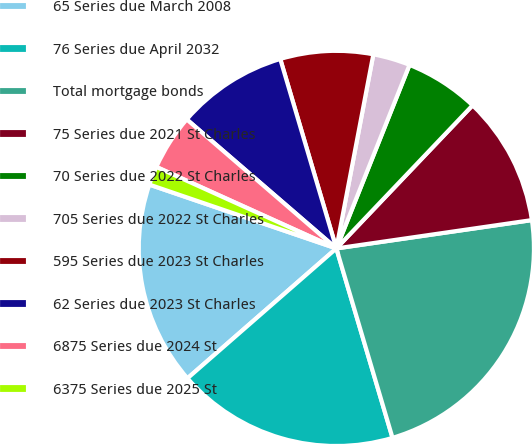Convert chart. <chart><loc_0><loc_0><loc_500><loc_500><pie_chart><fcel>65 Series due March 2008<fcel>76 Series due April 2032<fcel>Total mortgage bonds<fcel>75 Series due 2021 St Charles<fcel>70 Series due 2022 St Charles<fcel>705 Series due 2022 St Charles<fcel>595 Series due 2023 St Charles<fcel>62 Series due 2023 St Charles<fcel>6875 Series due 2024 St<fcel>6375 Series due 2025 St<nl><fcel>16.65%<fcel>18.17%<fcel>22.7%<fcel>10.6%<fcel>6.07%<fcel>3.04%<fcel>7.58%<fcel>9.09%<fcel>4.56%<fcel>1.53%<nl></chart> 